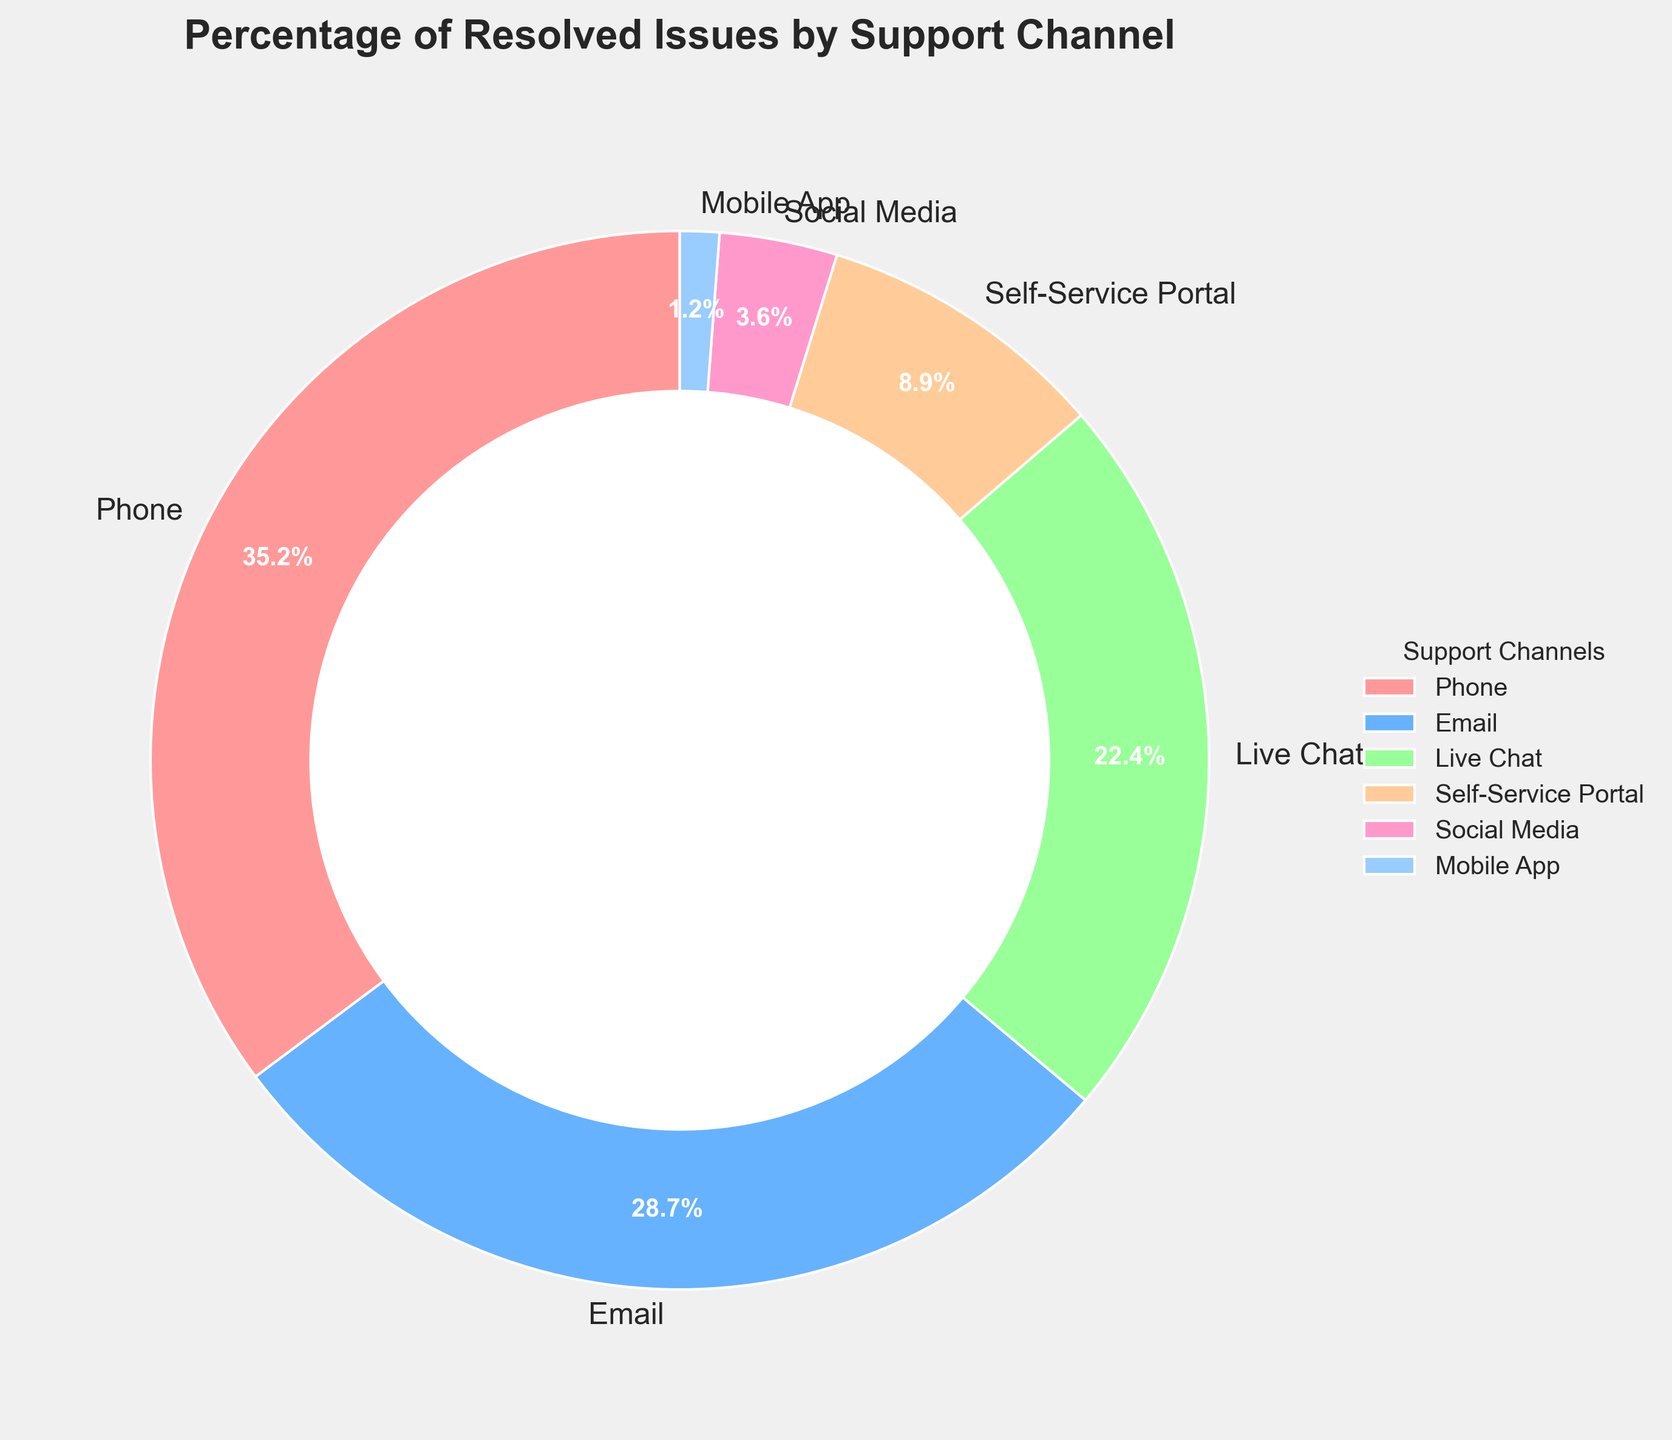What is the total percentage of resolved issues handled by Phone and Email channels? To find the total percentage of resolved issues handled by Phone and Email channels, sum the percentages of each channel: Phone is 35.2% and Email is 28.7%, so 35.2 + 28.7 = 63.9%.
Answer: 63.9% Which support channel has the lowest percentage of resolved issues? The support channel with the lowest percentage is identified by comparing all given percentages: Phone (35.2%), Email (28.7%), Live Chat (22.4%), Self-Service Portal (8.9%), Social Media (3.6%), and Mobile App (1.2%). Mobile App has the lowest at 1.2%.
Answer: Mobile App By how much does the percentage of issues resolved by Phone exceed those resolved by Live Chat? Subtract the percentage of Live Chat from the Phone percentage: Phone is 35.2% and Live Chat is 22.4%, so 35.2 - 22.4 = 12.8%.
Answer: 12.8% Which support channel has the second-highest percentage of resolved issues? The percentages are Phone (35.2%), Email (28.7%), Live Chat (22.4%), Self-Service Portal (8.9%), Social Media (3.6%), and Mobile App (1.2%). The second-highest percentage after Phone (35.2%) is Email, at 28.7%.
Answer: Email How does the sum of the percentages of Self-Service Portal and Social Media compare to Live Chat? Sum the percentages of Self-Service Portal and Social Media, then compare it with Live Chat: Self-Service Portal is 8.9% and Social Media is 3.6%, so 8.9 + 3.6 = 12.5%. Live Chat is 22.4%. Therefore, 12.5% is less than 22.4%.
Answer: Less than Live Chat If the total number of resolved issues is 10,000, how many were resolved via the Mobile App? Calculate the number based on the percentage for Mobile App: 1.2% of 10,000 is 10,000 * 0.012 = 120 issues.
Answer: 120 What is the difference in percentage between the channels with the highest and lowest resolved issues? Subtract the percentage of Mobile App (the lowest) from Phone (the highest): 35.2% - 1.2% = 34.0%.
Answer: 34.0% Among Phone, Email, and Live Chat, which channel resolves the most issues? Compare the percentages of Phone (35.2%), Email (28.7%), and Live Chat (22.4%). Phone has the highest percentage at 35.2%.
Answer: Phone What is the total percentage of issues resolved by lesser-used channels (Social Media, Mobile App, and Self-Service Portal)? Sum the percentages of Social Media, Mobile App, and Self-Service Portal: Social Media is 3.6%, Mobile App is 1.2%, and Self-Service Portal is 8.9%. So, 3.6 + 1.2 + 8.9 = 13.7%.
Answer: 13.7% Which support channel is represented by the light blue color in the pie chart? The light blue color represents the percentage associated with Email, which is 28.7%.
Answer: Email 